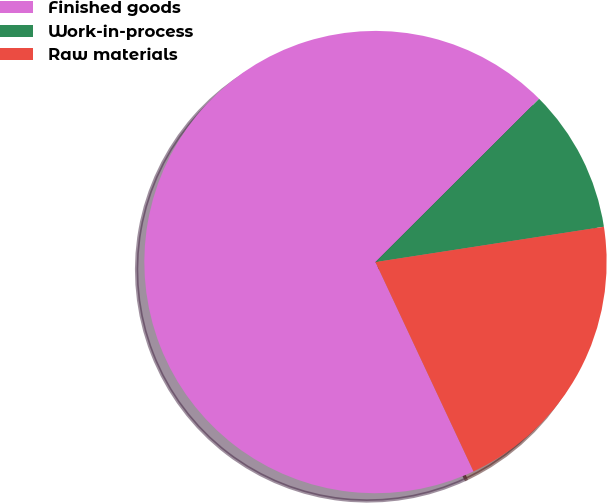<chart> <loc_0><loc_0><loc_500><loc_500><pie_chart><fcel>Finished goods<fcel>Work-in-process<fcel>Raw materials<nl><fcel>69.49%<fcel>10.04%<fcel>20.47%<nl></chart> 